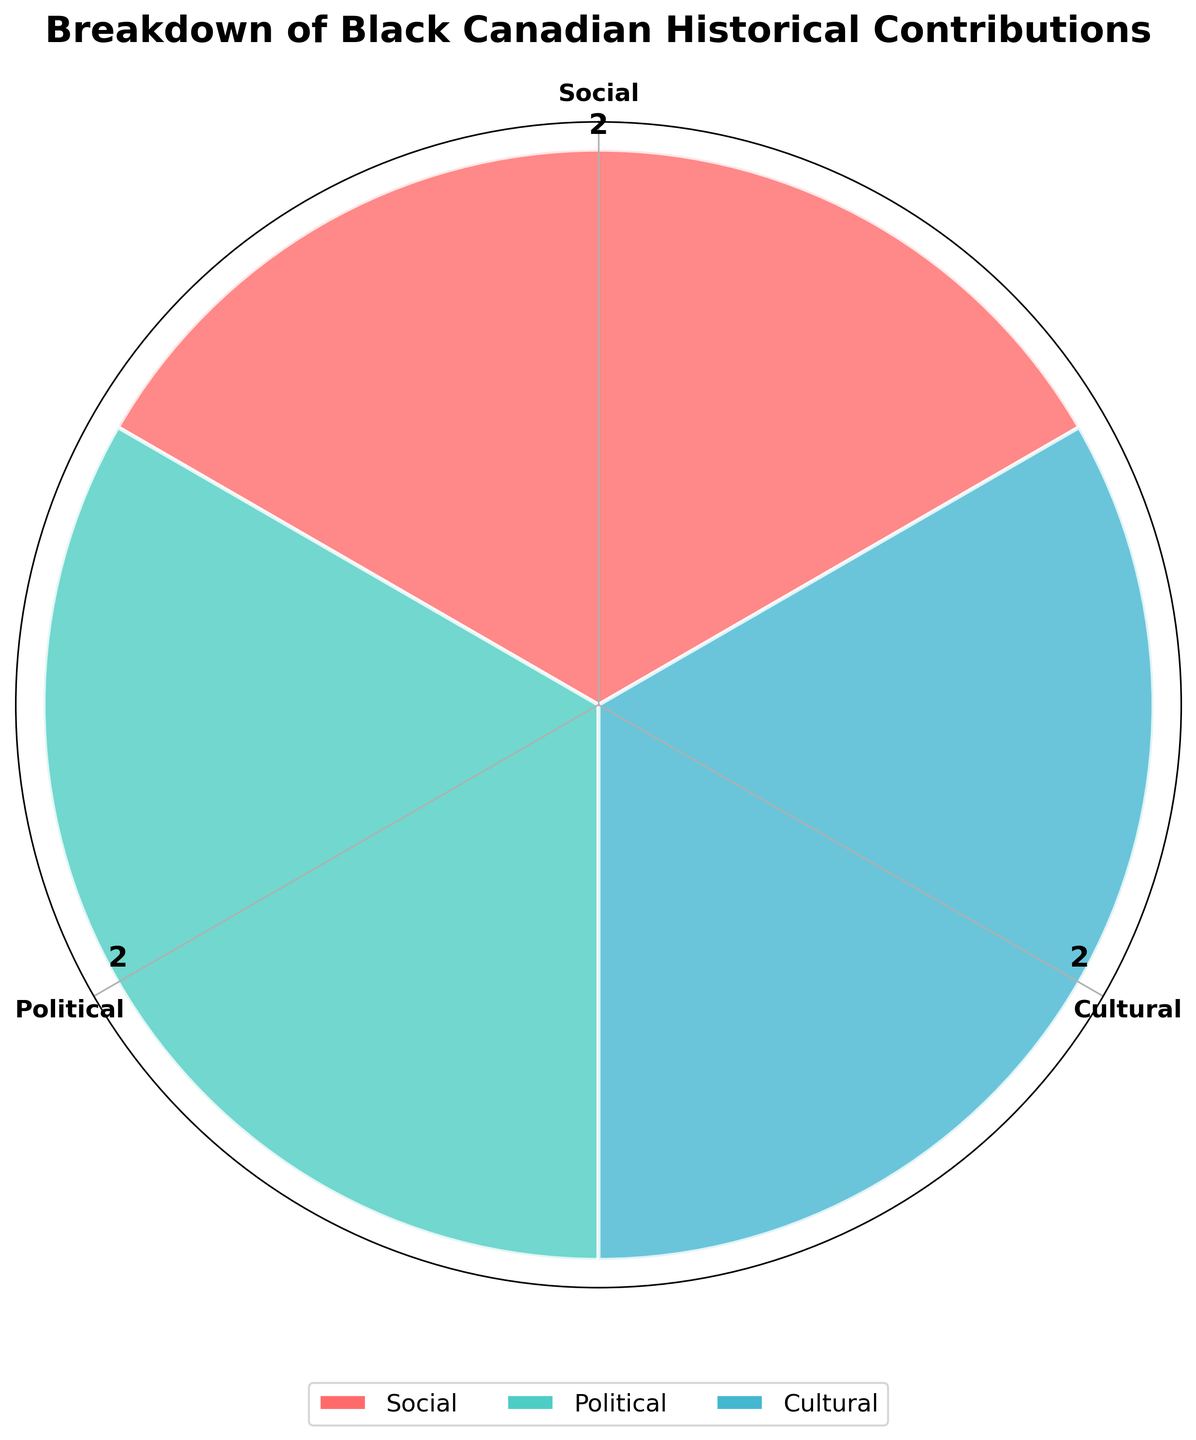What is the title of the rose chart? The title is usually positioned at the top of a chart and is intended to give a quick summary of what the chart represents. In this case, it is clearly labeled above the central point of the rose chart.
Answer: Breakdown of Black Canadian Historical Contributions How many categories of contributions are displayed in the rose chart? By looking at the number of distinct segments or wedges in the rose chart, we can determine the number of categories represented. Each segment is typically labeled with the category name.
Answer: 3 Which category has the highest number of contributions? By comparing the length of the segments in the rose chart, the category with the longest segment has the highest number of contributions. The corresponding label on the axis indicates the category.
Answer: Social What color represents the Cultural category in the rose chart? Each category in the rose chart is represented by a distinct color. We can match the segments to their respective labels to determine which color corresponds to the Cultural category.
Answer: Light blue How many contributions are there in the Political category? By looking at the segment labeled "Political" in the rose chart, we can see a number annotated next to it. This number represents the count of contributions in that category.
Answer: 2 What is the total number of contributions represented in the rose chart? To find the total number of contributions, sum the numbers annotated next to each category segment.
Answer: 6 Compare the number of contributions between Social and Cultural categories. Which one has more and by how much? Identify the annotated numbers for both Social and Cultural categories. Subtract the number for Cultural from the number for Social to find the difference.
Answer: Social has more by 1 contribution Is there any category that has the same number of contributions as another category? Compare the annotated numbers for all categories. If any two categories have the same number, they are equal.
Answer: Yes, Political and Cultural both have 2 contributions each What is the average number of contributions per category? Sum the total number of contributions and divide by the number of categories to find the average: (3+2+2)/3.
Answer: 2.33 Which category segment starts closest to the top (0°) of the rose chart? By identifying the segment whose leading edge is closest to 0° or the topmost position in the rose chart. This is usually aligned with the 12 o'clock position.
Answer: Social 